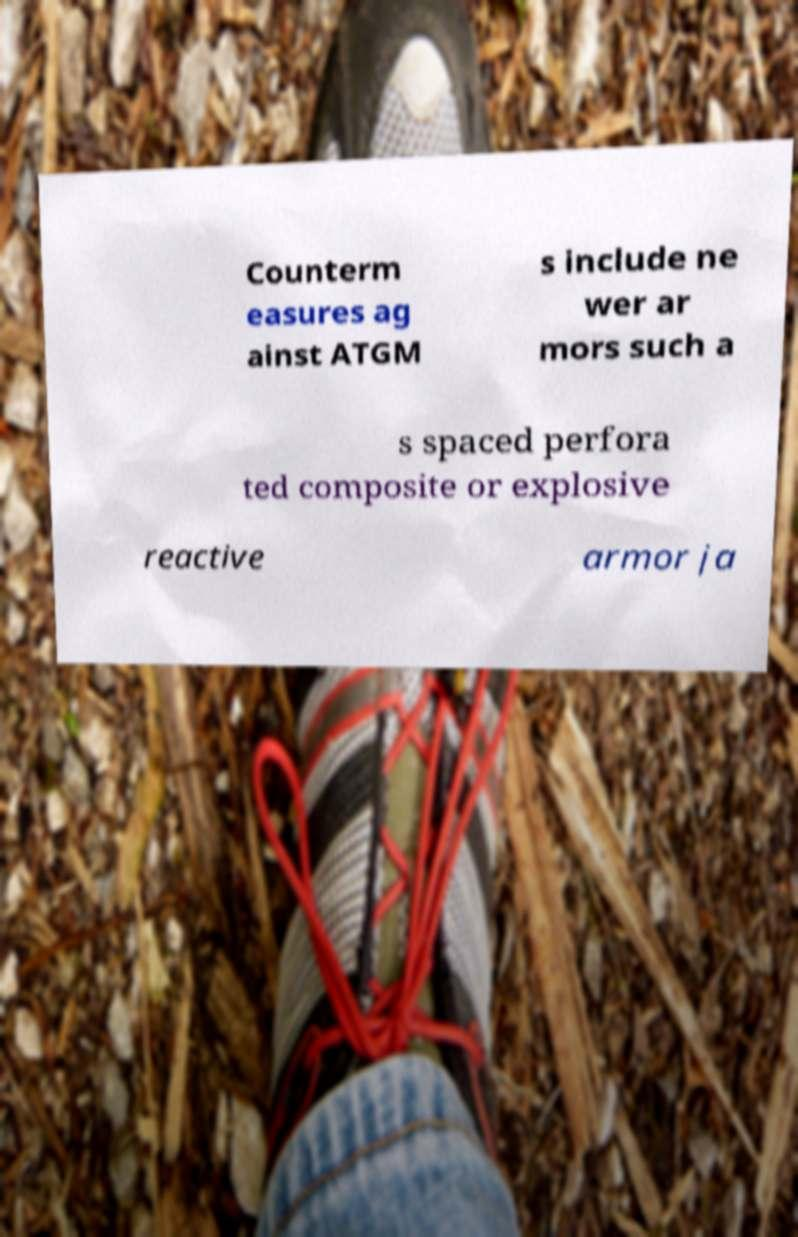Can you read and provide the text displayed in the image?This photo seems to have some interesting text. Can you extract and type it out for me? Counterm easures ag ainst ATGM s include ne wer ar mors such a s spaced perfora ted composite or explosive reactive armor ja 